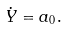Convert formula to latex. <formula><loc_0><loc_0><loc_500><loc_500>\dot { Y } = a _ { 0 } .</formula> 